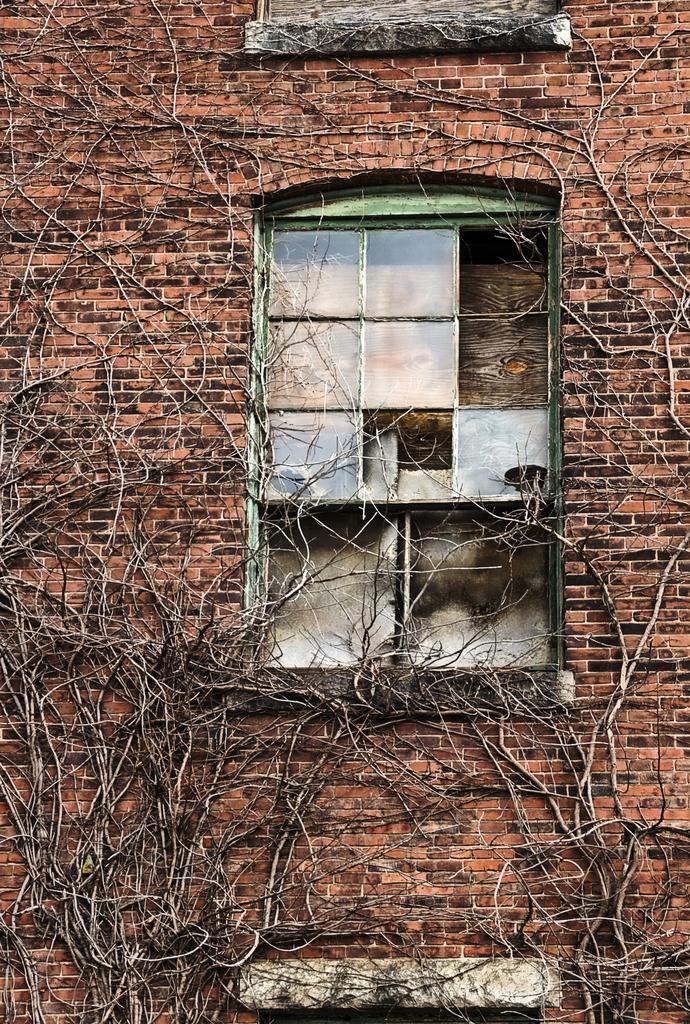Describe this image in one or two sentences. In this image few creepers are on the wall which is having windows. 